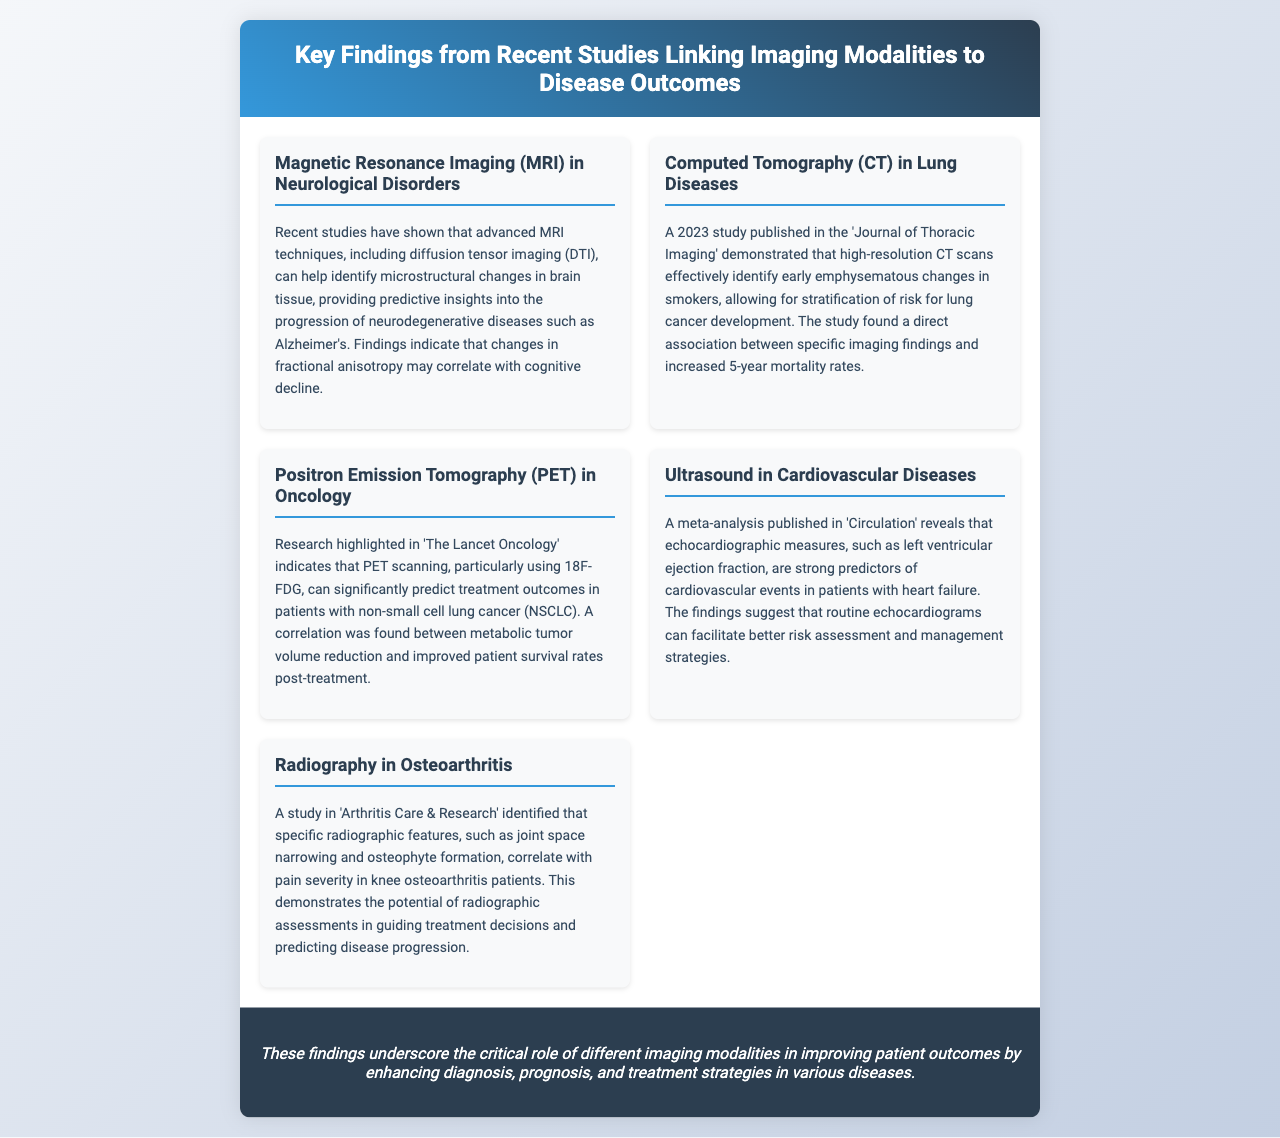What does DTI stand for? DTI is mentioned as diffusion tensor imaging, referring to a specific MRI technique used in neurological studies.
Answer: diffusion tensor imaging What imaging modality is effective for early emphysematous changes? The document states that high-resolution CT scans are effective in identifying early emphysematous changes in smokers.
Answer: high-resolution CT scans What correlation was found in the study related to NSCLC? The correlation mentioned is between metabolic tumor volume reduction and improved patient survival rates post-treatment.
Answer: metabolic tumor volume reduction Which echocardiographic measure predicts cardiovascular events? The document identifies left ventricular ejection fraction as a strong predictor of cardiovascular events in patients with heart failure.
Answer: left ventricular ejection fraction What specific radiographic features correlate with pain severity in knee osteoarthritis? The features mentioned are joint space narrowing and osteophyte formation that correlate with pain severity.
Answer: joint space narrowing and osteophyte formation What is the main conclusion of the findings? The conclusion summarizes that imaging modalities improve patient outcomes by enhancing diagnosis, prognosis, and treatment strategies.
Answer: improve patient outcomes In which publication is the study on lung diseases found? The study on lung diseases is published in the 'Journal of Thoracic Imaging'.
Answer: Journal of Thoracic Imaging What does the term "5-year mortality rates" refer to in this document? It refers to the association found between imaging findings identified in high-resolution CT scans and increased mortality rates for lung cancer.
Answer: 5-year mortality rates 